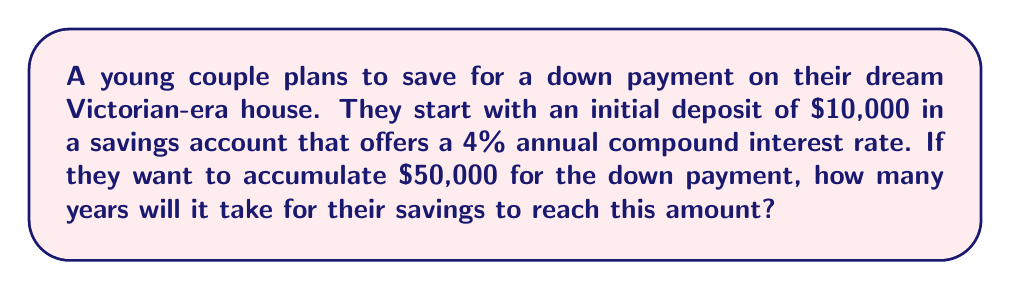Provide a solution to this math problem. To solve this problem, we'll use the compound interest formula, which is a geometric sequence:

$$A = P(1 + r)^n$$

Where:
$A$ = Final amount
$P$ = Principal (initial deposit)
$r$ = Annual interest rate (as a decimal)
$n$ = Number of years

We know:
$A = $50,000
$P = $10,000
$r = 0.04$ (4% as a decimal)

Let's substitute these values into the formula:

$$50,000 = 10,000(1 + 0.04)^n$$

Now, we need to solve for $n$:

1) Divide both sides by 10,000:
   $$5 = (1.04)^n$$

2) Take the natural log of both sides:
   $$\ln(5) = n \cdot \ln(1.04)$$

3) Solve for $n$:
   $$n = \frac{\ln(5)}{\ln(1.04)}$$

4) Calculate the result:
   $$n \approx 41.59$$

Since we can't have a partial year in this context, we round up to the next whole number.

Therefore, it will take 42 years for the savings to reach $50,000.
Answer: 42 years 